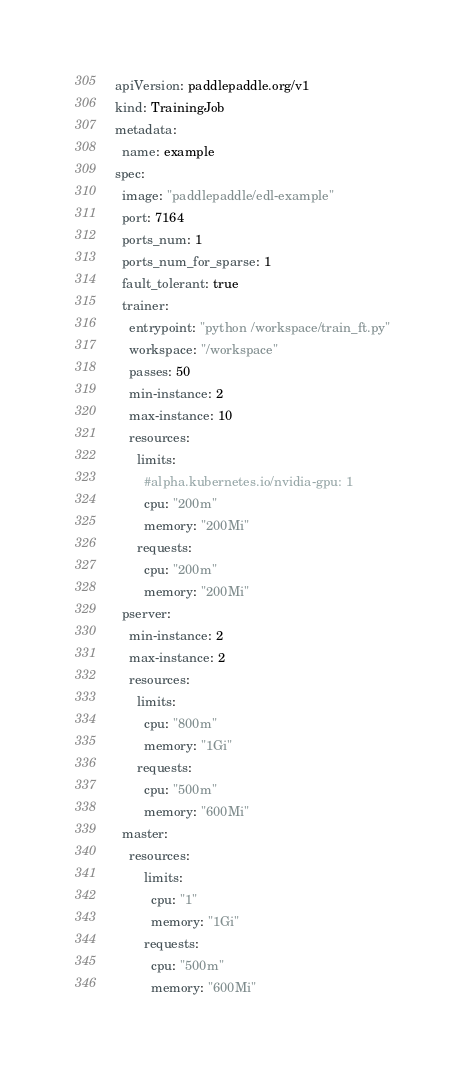<code> <loc_0><loc_0><loc_500><loc_500><_YAML_>apiVersion: paddlepaddle.org/v1
kind: TrainingJob
metadata:
  name: example
spec:
  image: "paddlepaddle/edl-example"
  port: 7164
  ports_num: 1
  ports_num_for_sparse: 1
  fault_tolerant: true
  trainer:
    entrypoint: "python /workspace/train_ft.py"
    workspace: "/workspace"
    passes: 50
    min-instance: 2
    max-instance: 10
    resources:
      limits:
        #alpha.kubernetes.io/nvidia-gpu: 1
        cpu: "200m"
        memory: "200Mi"
      requests:
        cpu: "200m"
        memory: "200Mi"
  pserver:
    min-instance: 2
    max-instance: 2
    resources:
      limits:
        cpu: "800m"
        memory: "1Gi"
      requests:
        cpu: "500m"
        memory: "600Mi"
  master:
    resources:
        limits:
          cpu: "1"
          memory: "1Gi"
        requests:
          cpu: "500m"
          memory: "600Mi"
</code> 